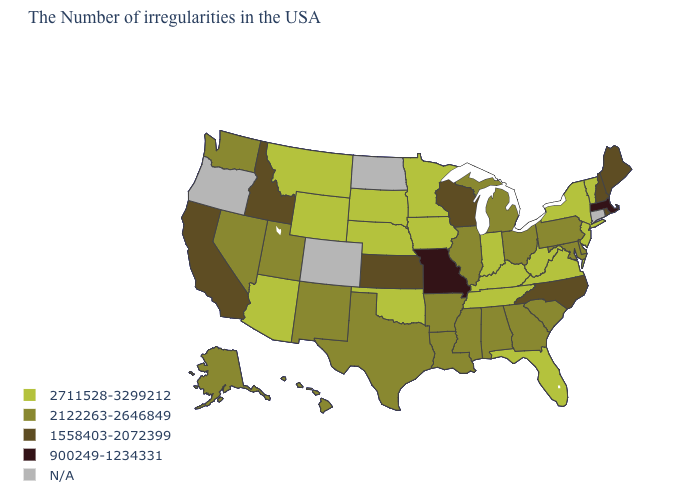Name the states that have a value in the range 2711528-3299212?
Give a very brief answer. Vermont, New York, New Jersey, Virginia, West Virginia, Florida, Kentucky, Indiana, Tennessee, Minnesota, Iowa, Nebraska, Oklahoma, South Dakota, Wyoming, Montana, Arizona. Name the states that have a value in the range 900249-1234331?
Concise answer only. Massachusetts, Missouri. What is the value of Minnesota?
Keep it brief. 2711528-3299212. Which states have the highest value in the USA?
Quick response, please. Vermont, New York, New Jersey, Virginia, West Virginia, Florida, Kentucky, Indiana, Tennessee, Minnesota, Iowa, Nebraska, Oklahoma, South Dakota, Wyoming, Montana, Arizona. What is the lowest value in the USA?
Quick response, please. 900249-1234331. Does the map have missing data?
Short answer required. Yes. Name the states that have a value in the range 2711528-3299212?
Concise answer only. Vermont, New York, New Jersey, Virginia, West Virginia, Florida, Kentucky, Indiana, Tennessee, Minnesota, Iowa, Nebraska, Oklahoma, South Dakota, Wyoming, Montana, Arizona. What is the lowest value in the Northeast?
Write a very short answer. 900249-1234331. Name the states that have a value in the range 2122263-2646849?
Concise answer only. Delaware, Maryland, Pennsylvania, South Carolina, Ohio, Georgia, Michigan, Alabama, Illinois, Mississippi, Louisiana, Arkansas, Texas, New Mexico, Utah, Nevada, Washington, Alaska, Hawaii. Does West Virginia have the lowest value in the South?
Write a very short answer. No. How many symbols are there in the legend?
Give a very brief answer. 5. What is the value of California?
Short answer required. 1558403-2072399. Is the legend a continuous bar?
Answer briefly. No. Name the states that have a value in the range 900249-1234331?
Keep it brief. Massachusetts, Missouri. Which states have the highest value in the USA?
Short answer required. Vermont, New York, New Jersey, Virginia, West Virginia, Florida, Kentucky, Indiana, Tennessee, Minnesota, Iowa, Nebraska, Oklahoma, South Dakota, Wyoming, Montana, Arizona. 